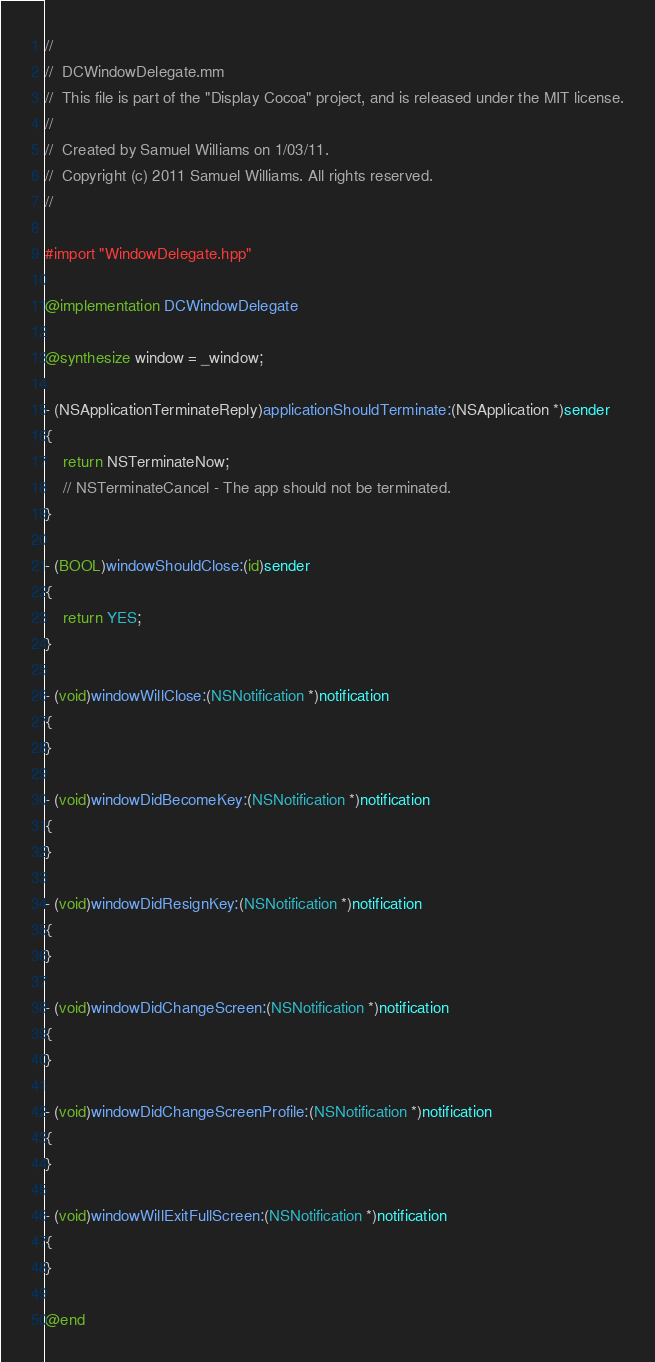<code> <loc_0><loc_0><loc_500><loc_500><_ObjectiveC_>//
//  DCWindowDelegate.mm
//  This file is part of the "Display Cocoa" project, and is released under the MIT license.
//
//  Created by Samuel Williams on 1/03/11.
//  Copyright (c) 2011 Samuel Williams. All rights reserved.
//

#import "WindowDelegate.hpp"

@implementation DCWindowDelegate

@synthesize window = _window;

- (NSApplicationTerminateReply)applicationShouldTerminate:(NSApplication *)sender
{
	return NSTerminateNow;
	// NSTerminateCancel - The app should not be terminated.
}

- (BOOL)windowShouldClose:(id)sender
{
	return YES;
}

- (void)windowWillClose:(NSNotification *)notification
{
}

- (void)windowDidBecomeKey:(NSNotification *)notification
{
}

- (void)windowDidResignKey:(NSNotification *)notification
{
}

- (void)windowDidChangeScreen:(NSNotification *)notification
{
}

- (void)windowDidChangeScreenProfile:(NSNotification *)notification
{
}

- (void)windowWillExitFullScreen:(NSNotification *)notification
{
}

@end
</code> 